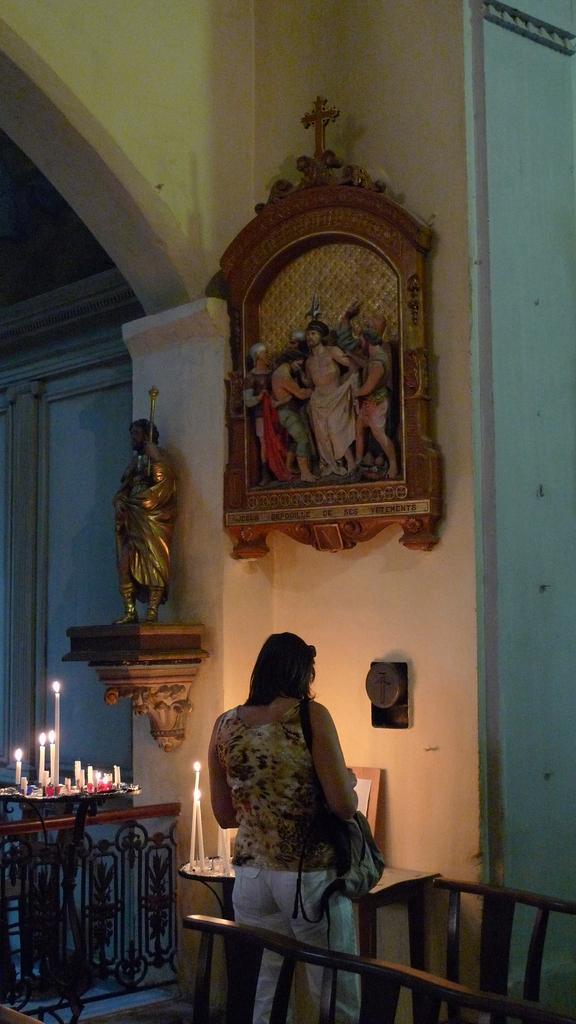How would you summarize this image in a sentence or two? This woman is standing and holding a handbag. In-front of this woman there is a table, on a table there are candles. On wall there are sculptures. 